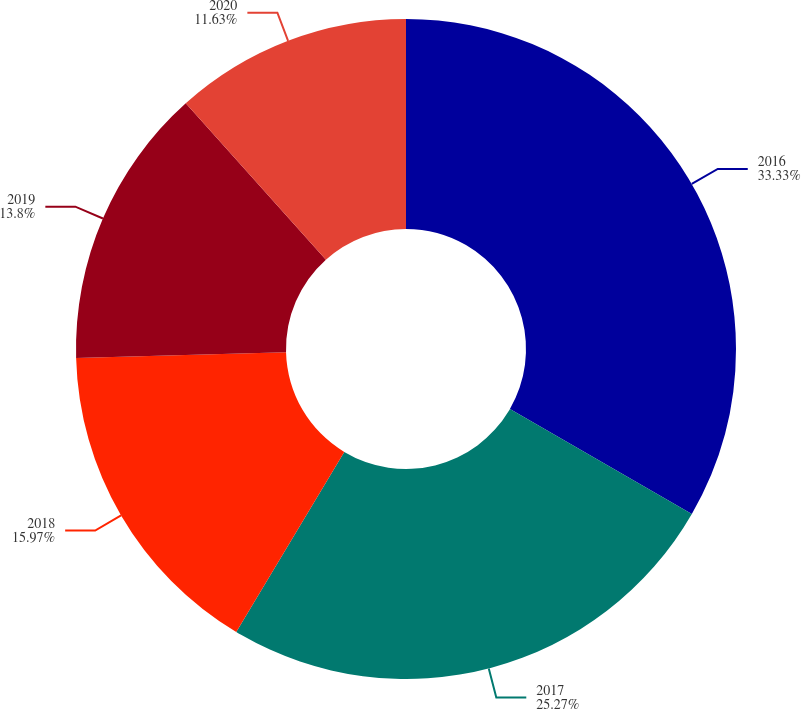Convert chart. <chart><loc_0><loc_0><loc_500><loc_500><pie_chart><fcel>2016<fcel>2017<fcel>2018<fcel>2019<fcel>2020<nl><fcel>33.33%<fcel>25.27%<fcel>15.97%<fcel>13.8%<fcel>11.63%<nl></chart> 